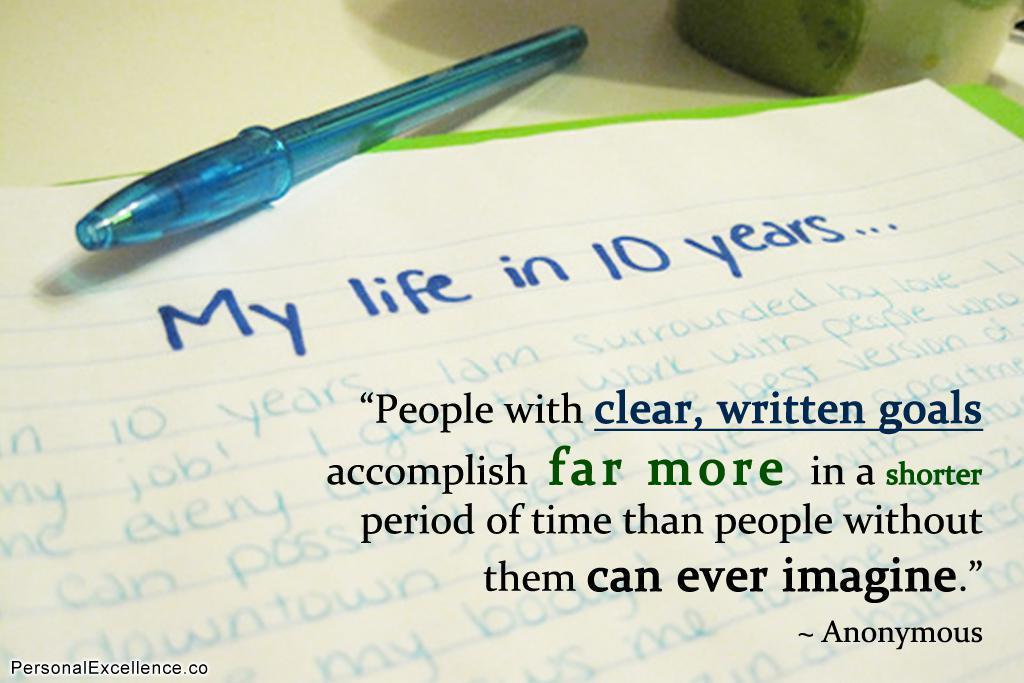Could you give a brief overview of what you see in this image? In this image, we can see a paper with some text and in the background, there is a pen and an object are on the table. 